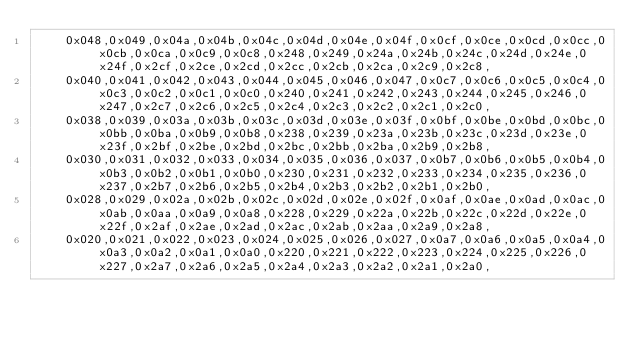Convert code to text. <code><loc_0><loc_0><loc_500><loc_500><_C_>	0x048,0x049,0x04a,0x04b,0x04c,0x04d,0x04e,0x04f,0x0cf,0x0ce,0x0cd,0x0cc,0x0cb,0x0ca,0x0c9,0x0c8,0x248,0x249,0x24a,0x24b,0x24c,0x24d,0x24e,0x24f,0x2cf,0x2ce,0x2cd,0x2cc,0x2cb,0x2ca,0x2c9,0x2c8,
	0x040,0x041,0x042,0x043,0x044,0x045,0x046,0x047,0x0c7,0x0c6,0x0c5,0x0c4,0x0c3,0x0c2,0x0c1,0x0c0,0x240,0x241,0x242,0x243,0x244,0x245,0x246,0x247,0x2c7,0x2c6,0x2c5,0x2c4,0x2c3,0x2c2,0x2c1,0x2c0,
	0x038,0x039,0x03a,0x03b,0x03c,0x03d,0x03e,0x03f,0x0bf,0x0be,0x0bd,0x0bc,0x0bb,0x0ba,0x0b9,0x0b8,0x238,0x239,0x23a,0x23b,0x23c,0x23d,0x23e,0x23f,0x2bf,0x2be,0x2bd,0x2bc,0x2bb,0x2ba,0x2b9,0x2b8,
	0x030,0x031,0x032,0x033,0x034,0x035,0x036,0x037,0x0b7,0x0b6,0x0b5,0x0b4,0x0b3,0x0b2,0x0b1,0x0b0,0x230,0x231,0x232,0x233,0x234,0x235,0x236,0x237,0x2b7,0x2b6,0x2b5,0x2b4,0x2b3,0x2b2,0x2b1,0x2b0,
	0x028,0x029,0x02a,0x02b,0x02c,0x02d,0x02e,0x02f,0x0af,0x0ae,0x0ad,0x0ac,0x0ab,0x0aa,0x0a9,0x0a8,0x228,0x229,0x22a,0x22b,0x22c,0x22d,0x22e,0x22f,0x2af,0x2ae,0x2ad,0x2ac,0x2ab,0x2aa,0x2a9,0x2a8,
	0x020,0x021,0x022,0x023,0x024,0x025,0x026,0x027,0x0a7,0x0a6,0x0a5,0x0a4,0x0a3,0x0a2,0x0a1,0x0a0,0x220,0x221,0x222,0x223,0x224,0x225,0x226,0x227,0x2a7,0x2a6,0x2a5,0x2a4,0x2a3,0x2a2,0x2a1,0x2a0,</code> 